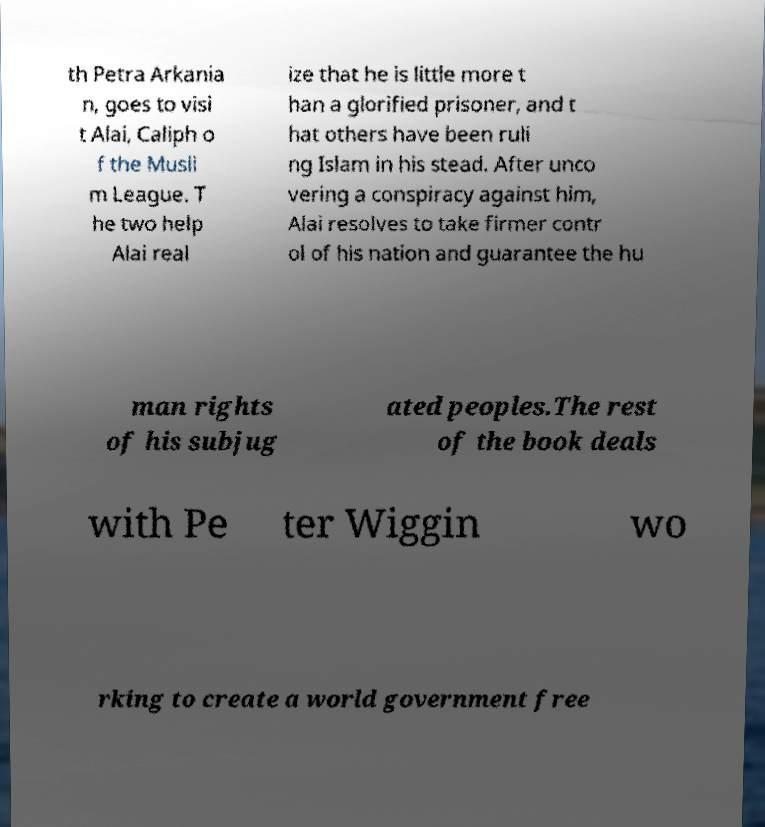What messages or text are displayed in this image? I need them in a readable, typed format. th Petra Arkania n, goes to visi t Alai, Caliph o f the Musli m League. T he two help Alai real ize that he is little more t han a glorified prisoner, and t hat others have been ruli ng Islam in his stead. After unco vering a conspiracy against him, Alai resolves to take firmer contr ol of his nation and guarantee the hu man rights of his subjug ated peoples.The rest of the book deals with Pe ter Wiggin wo rking to create a world government free 